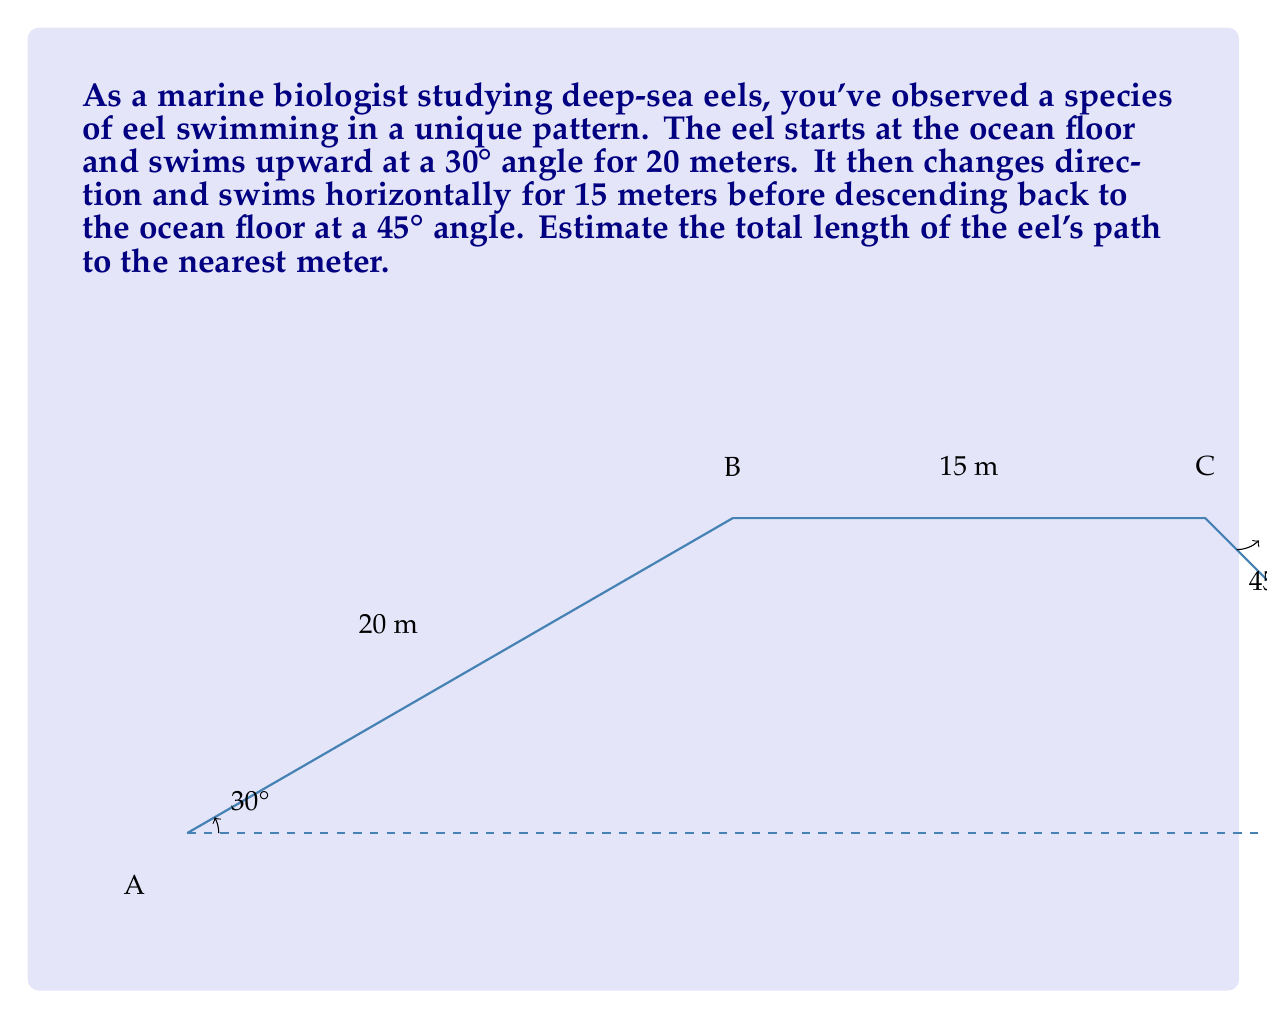Give your solution to this math problem. To solve this problem, we'll break it down into three segments and use trigonometric functions to calculate the length of each segment.

1. First segment (AB):
   We're given that this segment is 20 meters long at a 30° angle.

2. Second segment (BC):
   This is a horizontal segment 15 meters long.

3. Third segment (CD):
   We need to calculate this using the right triangle formed by points C, D, and the ocean floor.

Let's calculate the length of CD:

The vertical height of point C can be found using the first segment:
$$ \text{Height} = 20 \sin(30°) = 20 \cdot 0.5 = 10 \text{ meters} $$

Now we have a right triangle where:
- The vertical side (height) is 10 meters
- The angle with the hypotenuse is 45°

We can use the sine function to find the length of CD:

$$ \sin(45°) = \frac{10}{\text{CD}} $$

$$ \text{CD} = \frac{10}{\sin(45°)} = \frac{10}{\frac{\sqrt{2}}{2}} = 10\sqrt{2} \approx 14.14 \text{ meters} $$

Now we can sum up all three segments:

$$ \text{Total length} = 20 + 15 + 10\sqrt{2} \approx 20 + 15 + 14.14 = 49.14 \text{ meters} $$

Rounding to the nearest meter, we get 49 meters.
Answer: 49 meters 